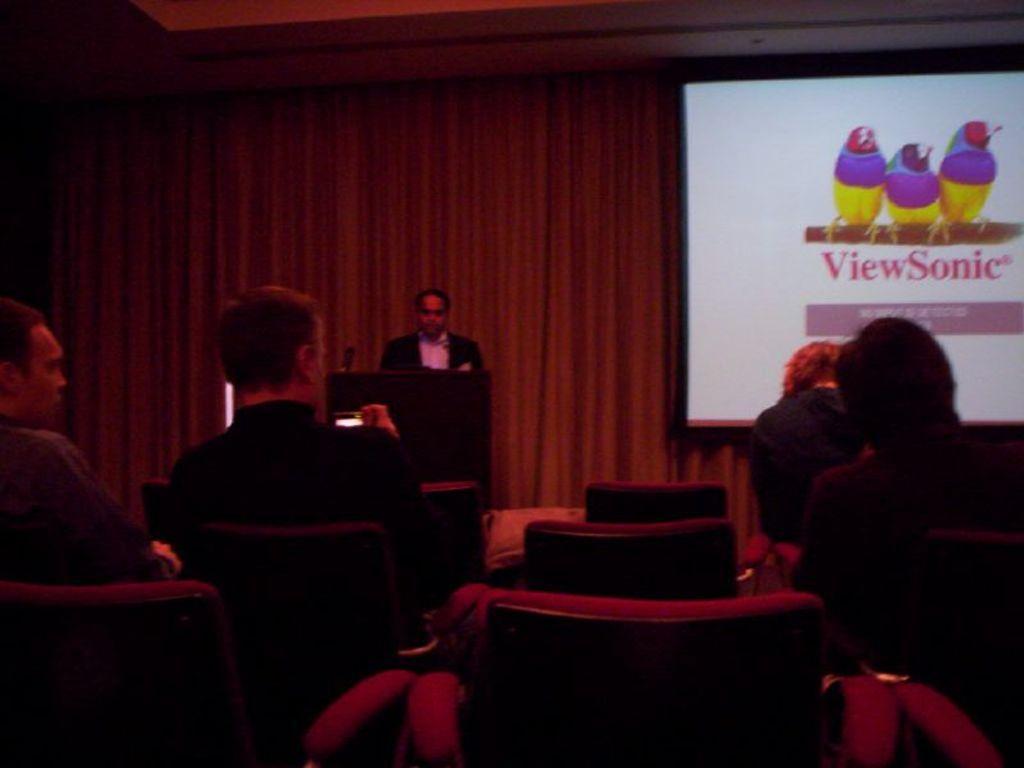Describe this image in one or two sentences. In this image there are a few people sitting on their chairs, in front of them there is a person standing in front of the table. On the table there is a mic. In the background there is a screen and curtains. 